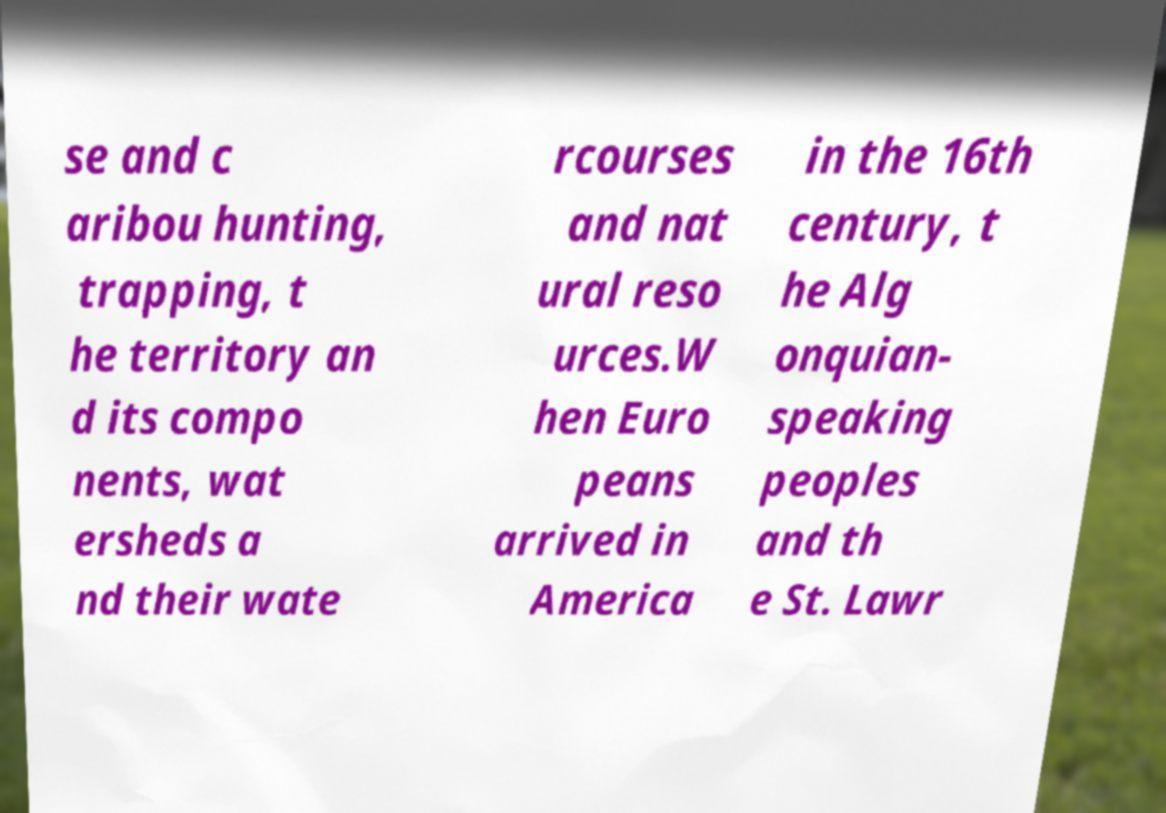Could you extract and type out the text from this image? se and c aribou hunting, trapping, t he territory an d its compo nents, wat ersheds a nd their wate rcourses and nat ural reso urces.W hen Euro peans arrived in America in the 16th century, t he Alg onquian- speaking peoples and th e St. Lawr 